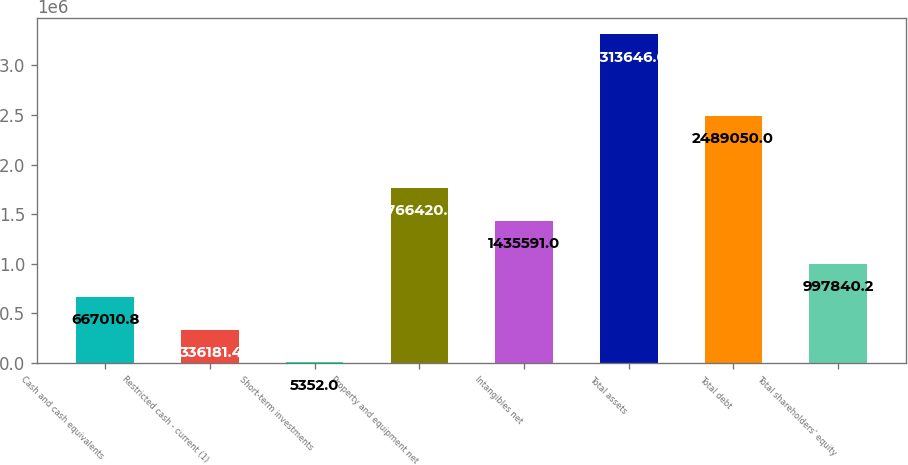Convert chart to OTSL. <chart><loc_0><loc_0><loc_500><loc_500><bar_chart><fcel>Cash and cash equivalents<fcel>Restricted cash - current (1)<fcel>Short-term investments<fcel>Property and equipment net<fcel>Intangibles net<fcel>Total assets<fcel>Total debt<fcel>Total shareholders' equity<nl><fcel>667011<fcel>336181<fcel>5352<fcel>1.76642e+06<fcel>1.43559e+06<fcel>3.31365e+06<fcel>2.48905e+06<fcel>997840<nl></chart> 